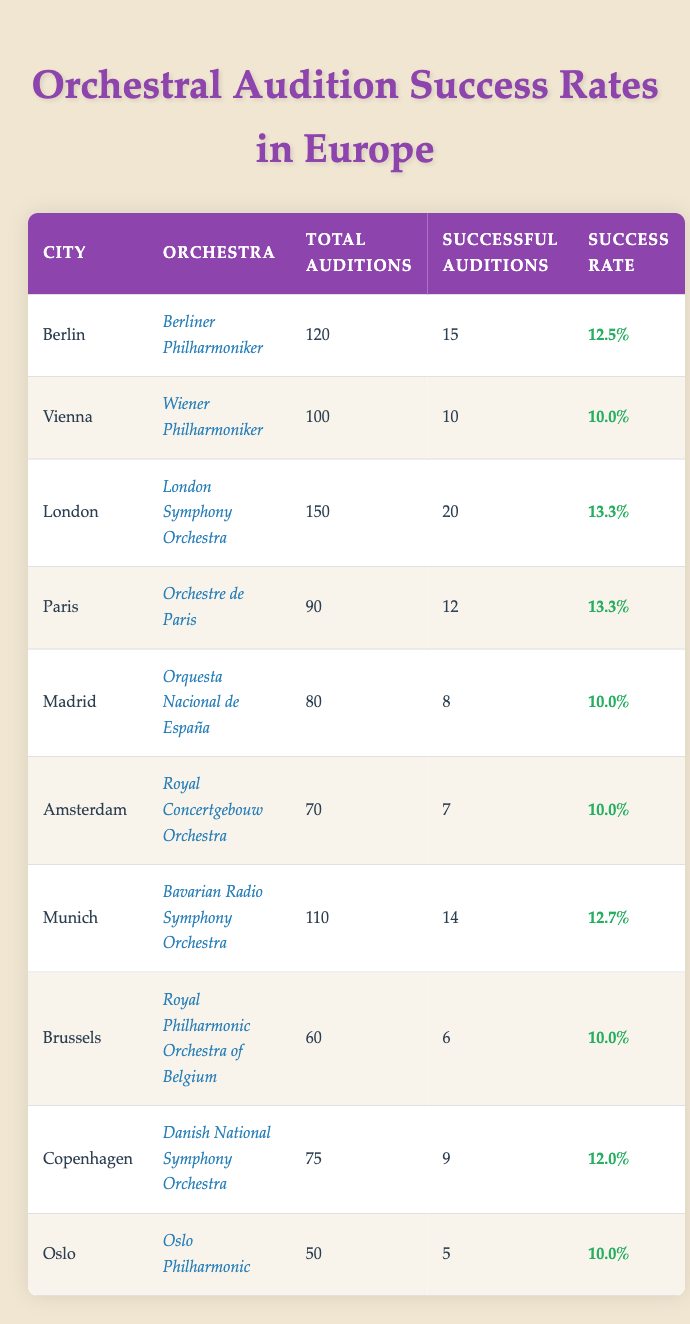What is the city with the highest success rate? In the table, we look for the city with the highest value in the "Success Rate" column. By comparing the success rates, we see that both London and Paris have a success rate of 13.3%, which is the highest among all cities.
Answer: London and Paris How many total auditions were held in Berlin? The table lists the total auditions for each city. For Berlin, the "Total Auditions" column shows the value as 120.
Answer: 120 What is the average success rate of auditions across all cities? To find the average success rate, we need to sum the success rates listed (12.5 + 10.0 + 13.3 + 13.3 + 10.0 + 10.0 + 12.7 + 10.0 + 12.0 + 10.0 =  12.5) and divide by the number of cities (10). The total success rate summed is  12.5 and then divided by 10 gives us 12.5/10 = 12.25.
Answer: 12.25 Is the success rate for auditions in Munich greater than that of Brussels? Looking at the "Success Rate" column, Munich has a success rate of 12.7%, while Brussels has a success rate of 10.0%. Since 12.7% is greater than 10.0%, we can conclude that yes, Munich's success rate is greater than Brussels.
Answer: Yes How many successful auditions were there in total for all orchestras combined? The total successful auditions can be calculated by summing the "Successful Auditions" from each city (15 + 10 + 20 + 12 + 8 + 7 + 14 + 6 + 9 + 5 = 116). Therefore, the combined total of successful auditions is 116.
Answer: 116 Which city has the least number of successful auditions? We look at the "Successful Auditions" column for the lowest value. The lowest number is 5, which is from Oslo. Therefore, Oslo has the least number of successful auditions.
Answer: Oslo Is there any city where the success rate is exactly 10%? Checking the "Success Rate" column, we find that Vienna, Madrid, Amsterdam, Brussels, and Oslo all have a success rate of 10.0%. Thus, there are cities with a success rate of exactly 10%.
Answer: Yes What is the difference in total auditions between London and Madrid? The total auditions for London and Madrid are 150 and 80, respectively. To find the difference, we subtract: 150 - 80 = 70. Thus, the difference in total auditions is 70.
Answer: 70 